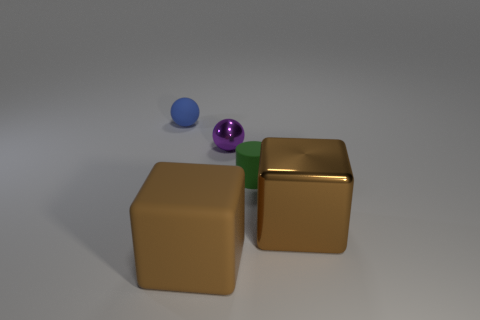Add 2 small blue metallic things. How many objects exist? 7 Subtract all blue spheres. How many spheres are left? 1 Subtract 2 blocks. How many blocks are left? 0 Add 5 purple blocks. How many purple blocks exist? 5 Subtract 0 gray cubes. How many objects are left? 5 Subtract all cylinders. How many objects are left? 4 Subtract all blue blocks. Subtract all green cylinders. How many blocks are left? 2 Subtract all small rubber cylinders. Subtract all big blue matte objects. How many objects are left? 4 Add 1 brown metal objects. How many brown metal objects are left? 2 